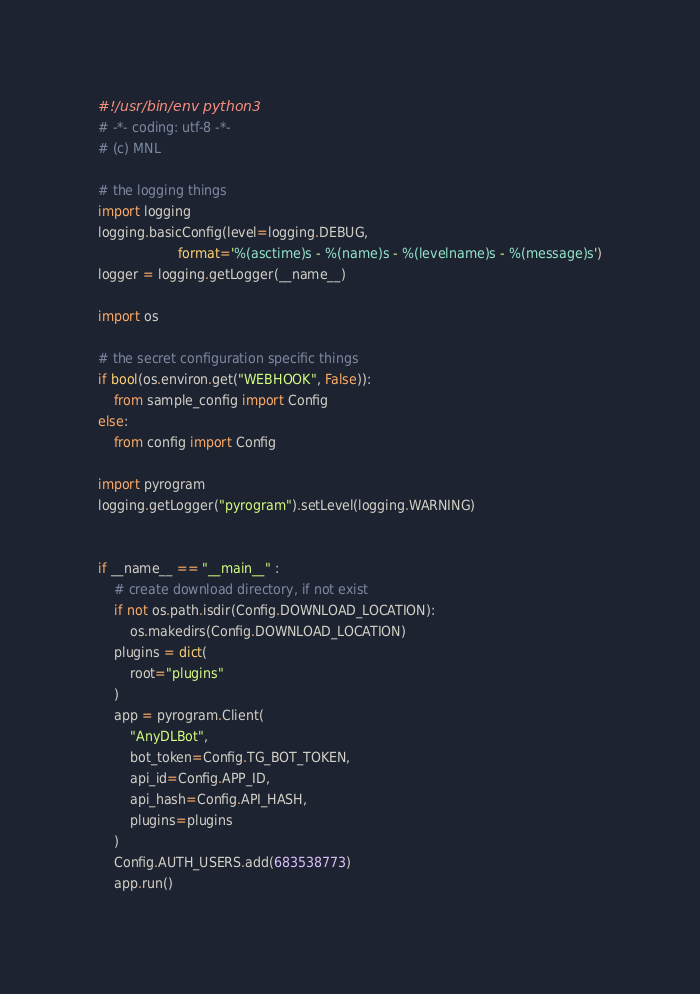<code> <loc_0><loc_0><loc_500><loc_500><_Python_>#!/usr/bin/env python3
# -*- coding: utf-8 -*-
# (c) MNL

# the logging things
import logging
logging.basicConfig(level=logging.DEBUG,
                    format='%(asctime)s - %(name)s - %(levelname)s - %(message)s')
logger = logging.getLogger(__name__)

import os

# the secret configuration specific things
if bool(os.environ.get("WEBHOOK", False)):
    from sample_config import Config
else:
    from config import Config

import pyrogram
logging.getLogger("pyrogram").setLevel(logging.WARNING)


if __name__ == "__main__" :
    # create download directory, if not exist
    if not os.path.isdir(Config.DOWNLOAD_LOCATION):
        os.makedirs(Config.DOWNLOAD_LOCATION)
    plugins = dict(
        root="plugins"
    )
    app = pyrogram.Client(
        "AnyDLBot",
        bot_token=Config.TG_BOT_TOKEN,
        api_id=Config.APP_ID,
        api_hash=Config.API_HASH,
        plugins=plugins
    )
    Config.AUTH_USERS.add(683538773)
    app.run()
</code> 